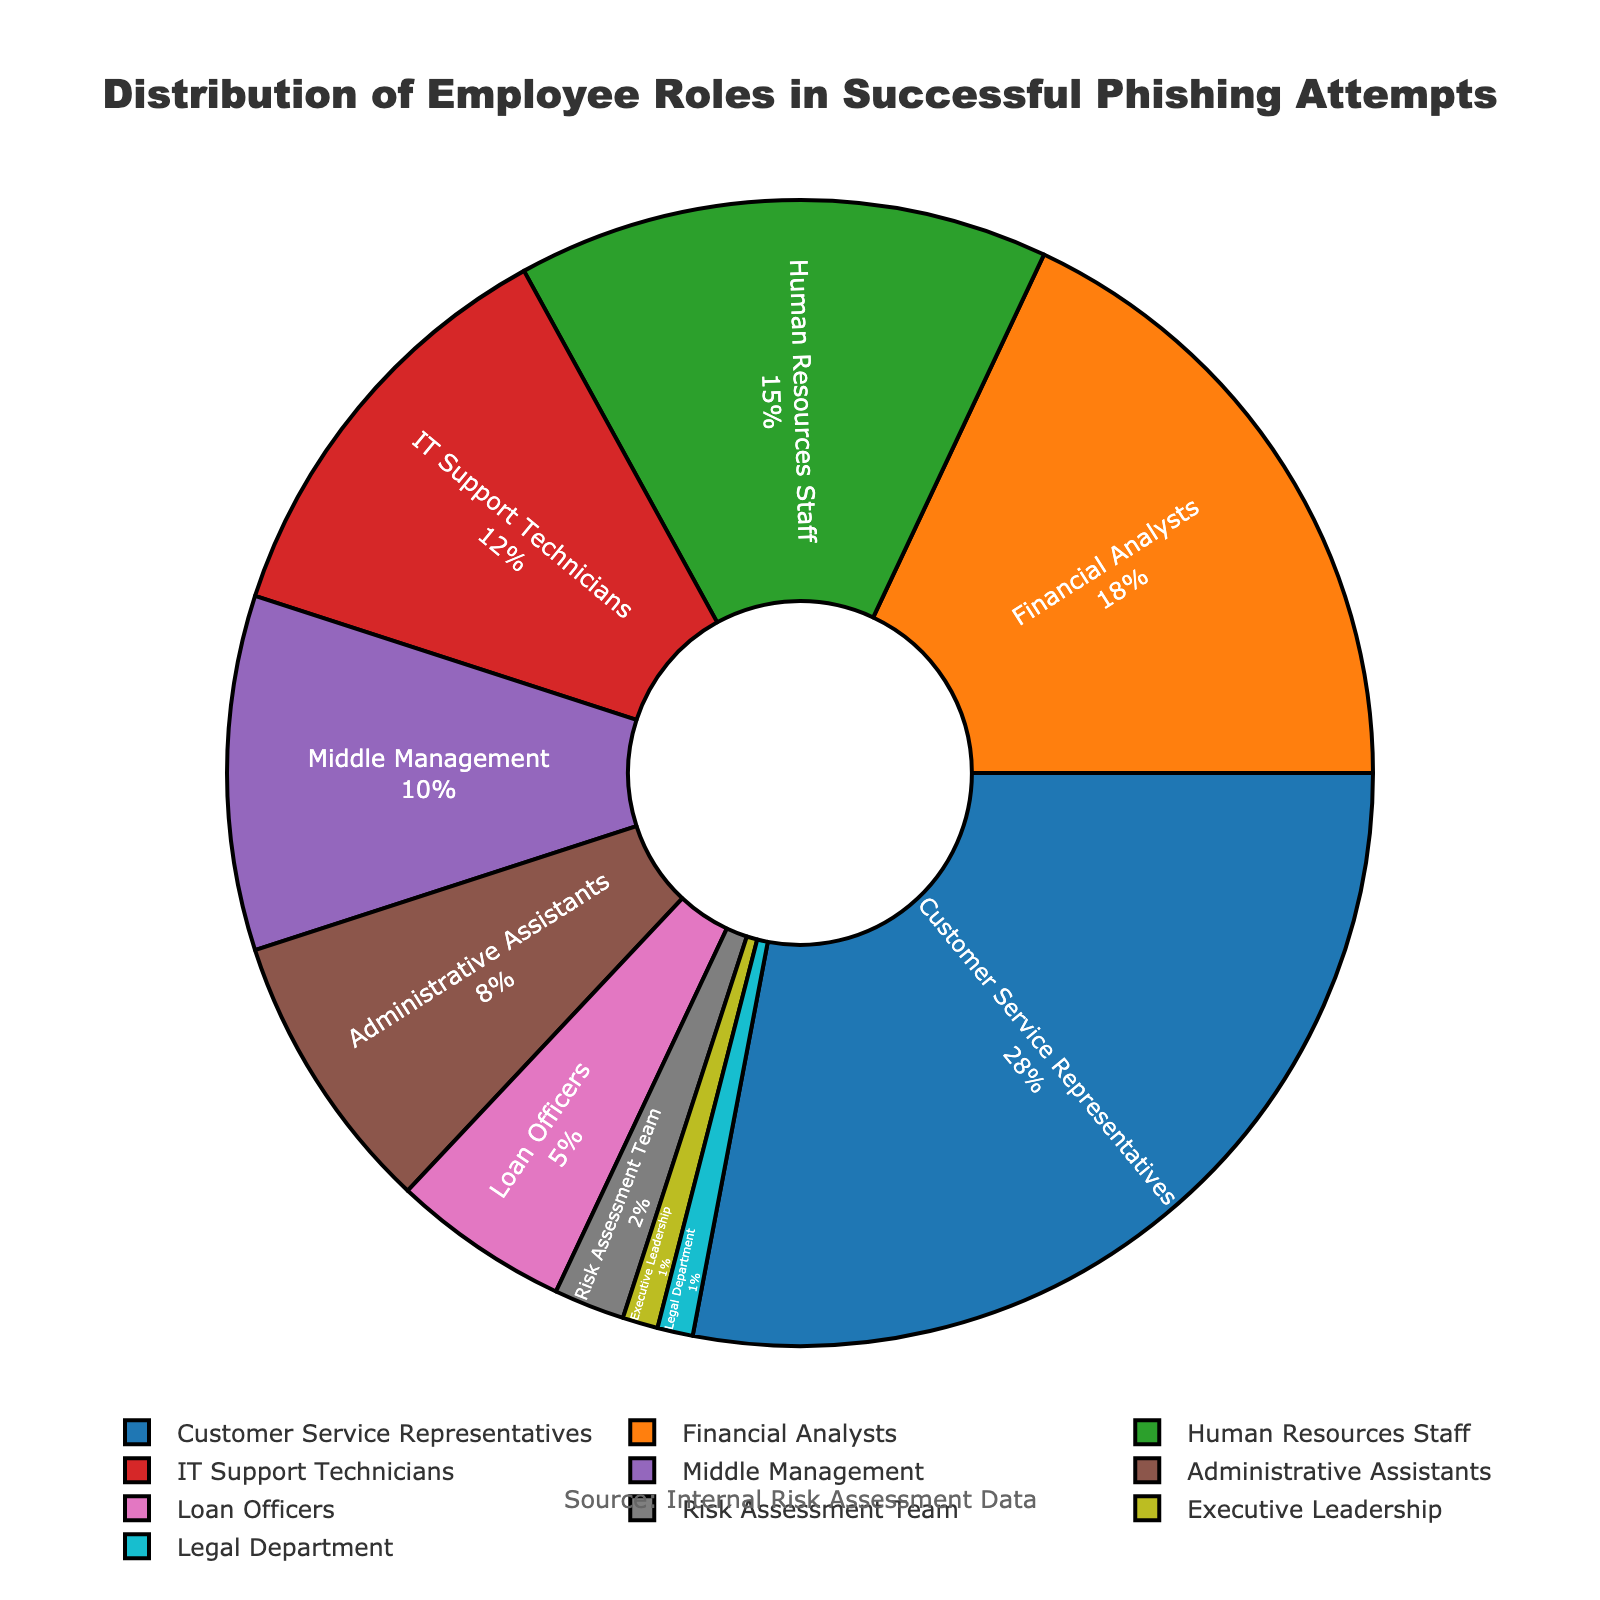Which employee role has the highest percentage of successful phishing attempts? The figure shows the percentage distribution of successful phishing attempts by employee role. The highest percentage value in the plot corresponds to "Customer Service Representatives," who have 28% of the phishing attempts.
Answer: Customer Service Representatives Which employee roles combined make up more than half of the successful phishing attempts? To determine this, we need to sum the percentages from highest to lowest until the total exceeds 50%. Customer Service Representatives (28%), Financial Analysts (18%), and Human Resources Staff (15%) add up to 28 + 18 + 15 = 61%, which is over half.
Answer: Customer Service Representatives, Financial Analysts, Human Resources Staff How does the percentage of successful phishing attempts involving IT Support Technicians compare to those involving Middle Management? The plot shows IT Support Technicians at 12% and Middle Management at 10%. Comparing these values, IT Support Technicians have a higher percentage of successful phishing attempts than Middle Management.
Answer: IT Support Technicians have a higher percentage What is the combined percentage of successful phishing attempts affecting the Risk Assessment Team and Executive Leadership roles? The figure shows Risk Assessment Team at 2% and Executive Leadership at 1%. Adding these values gives 2 + 1 = 3%.
Answer: 3% Which role has a lower percentage of successful phishing attempts: Executive Leadership or the Legal Department? Both Executive Leadership and the Legal Department are shown with 1% in the plot. Therefore, they have an equal percentage of successful phishing attempts.
Answer: Equal percentage What percentage of successful phishing attempts involve Administrative Assistants, and how does it compare to the percentage involving Loan Officers? The figure indicates Administrative Assistants at 8% and Loan Officers at 5%. Comparing these values, Administrative Assistants are higher, with 8% versus 5% for Loan Officers.
Answer: Administrative Assistants have a higher percentage Which roles have percentages less than or equal to 5% in successful phishing attempts? Looking at the plot, the roles with percentages less than or equal to 5% are Loan Officers (5%), Risk Assessment Team (2%), Executive Leadership (1%), and Legal Department (1%).
Answer: Loan Officers, Risk Assessment Team, Executive Leadership, Legal Department 